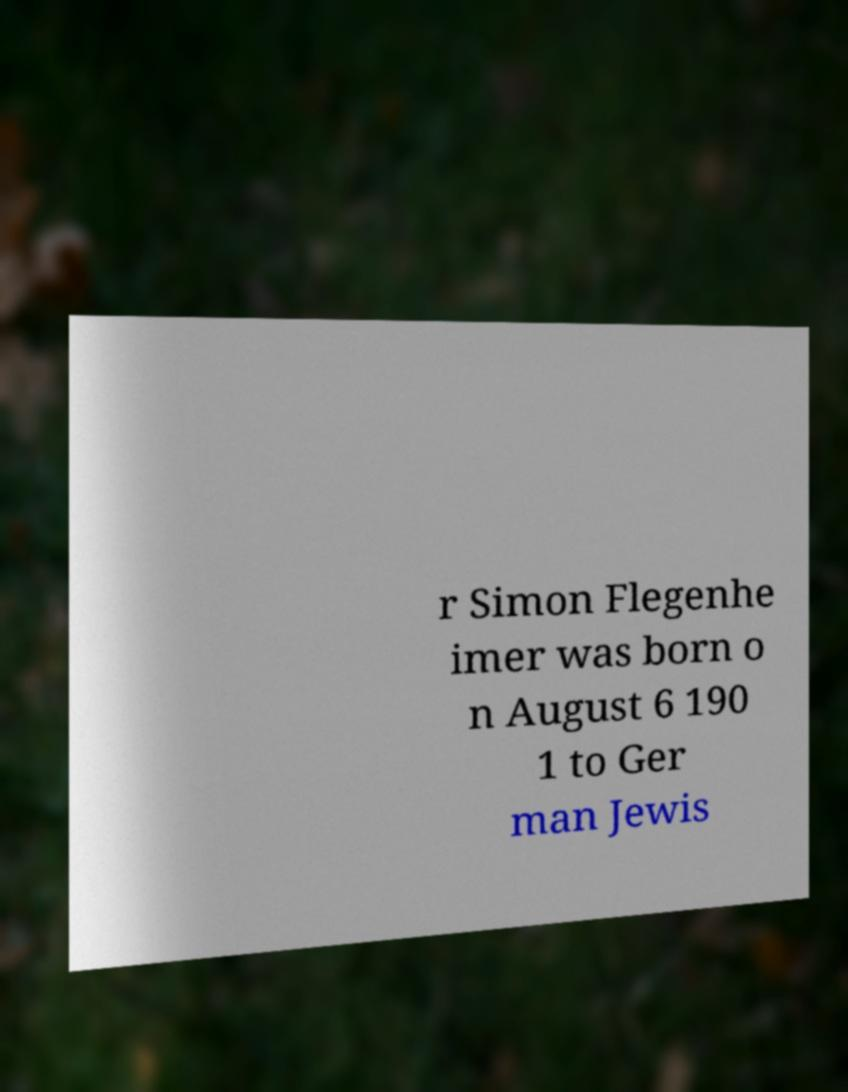What messages or text are displayed in this image? I need them in a readable, typed format. r Simon Flegenhe imer was born o n August 6 190 1 to Ger man Jewis 